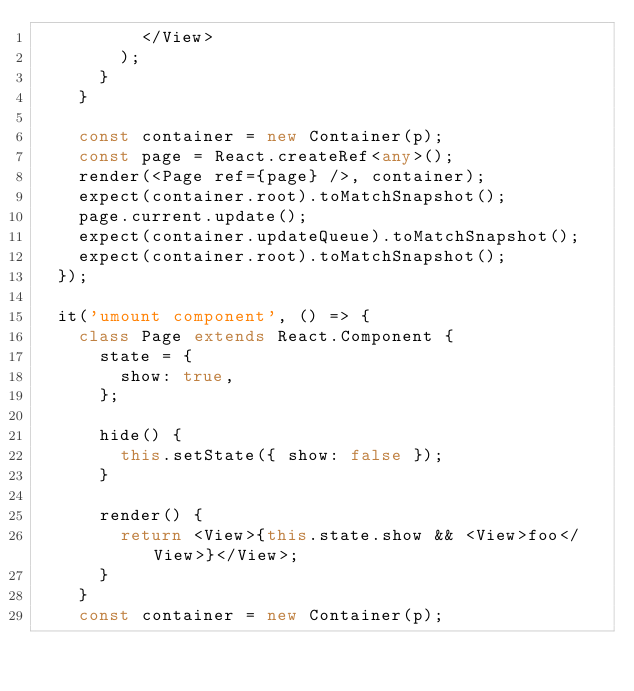<code> <loc_0><loc_0><loc_500><loc_500><_TypeScript_>          </View>
        );
      }
    }

    const container = new Container(p);
    const page = React.createRef<any>();
    render(<Page ref={page} />, container);
    expect(container.root).toMatchSnapshot();
    page.current.update();
    expect(container.updateQueue).toMatchSnapshot();
    expect(container.root).toMatchSnapshot();
  });

  it('umount component', () => {
    class Page extends React.Component {
      state = {
        show: true,
      };

      hide() {
        this.setState({ show: false });
      }

      render() {
        return <View>{this.state.show && <View>foo</View>}</View>;
      }
    }
    const container = new Container(p);</code> 